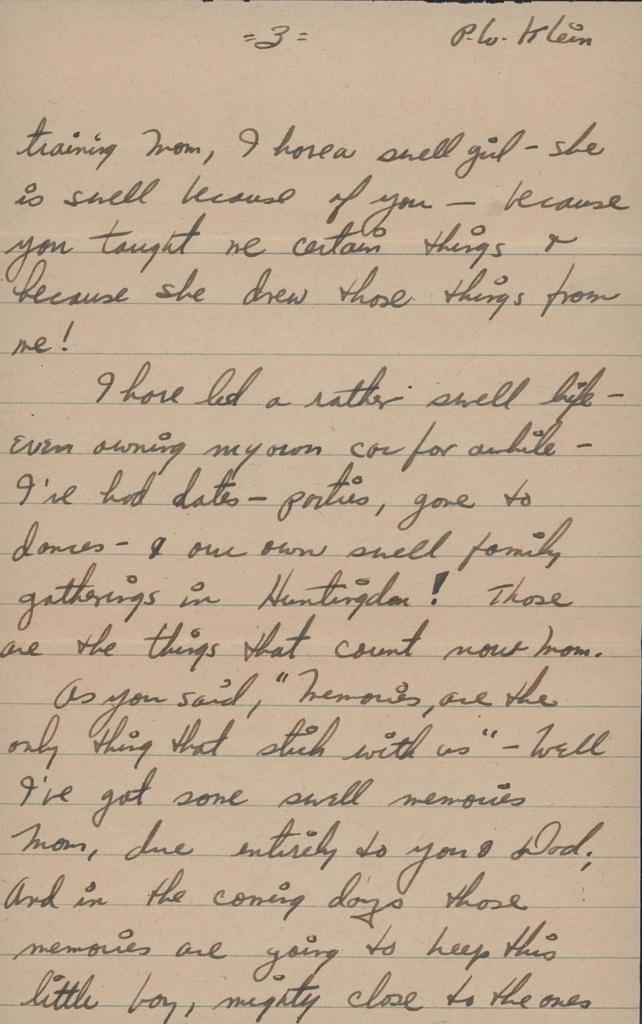What number is the page?
Keep it short and to the point. 3. 